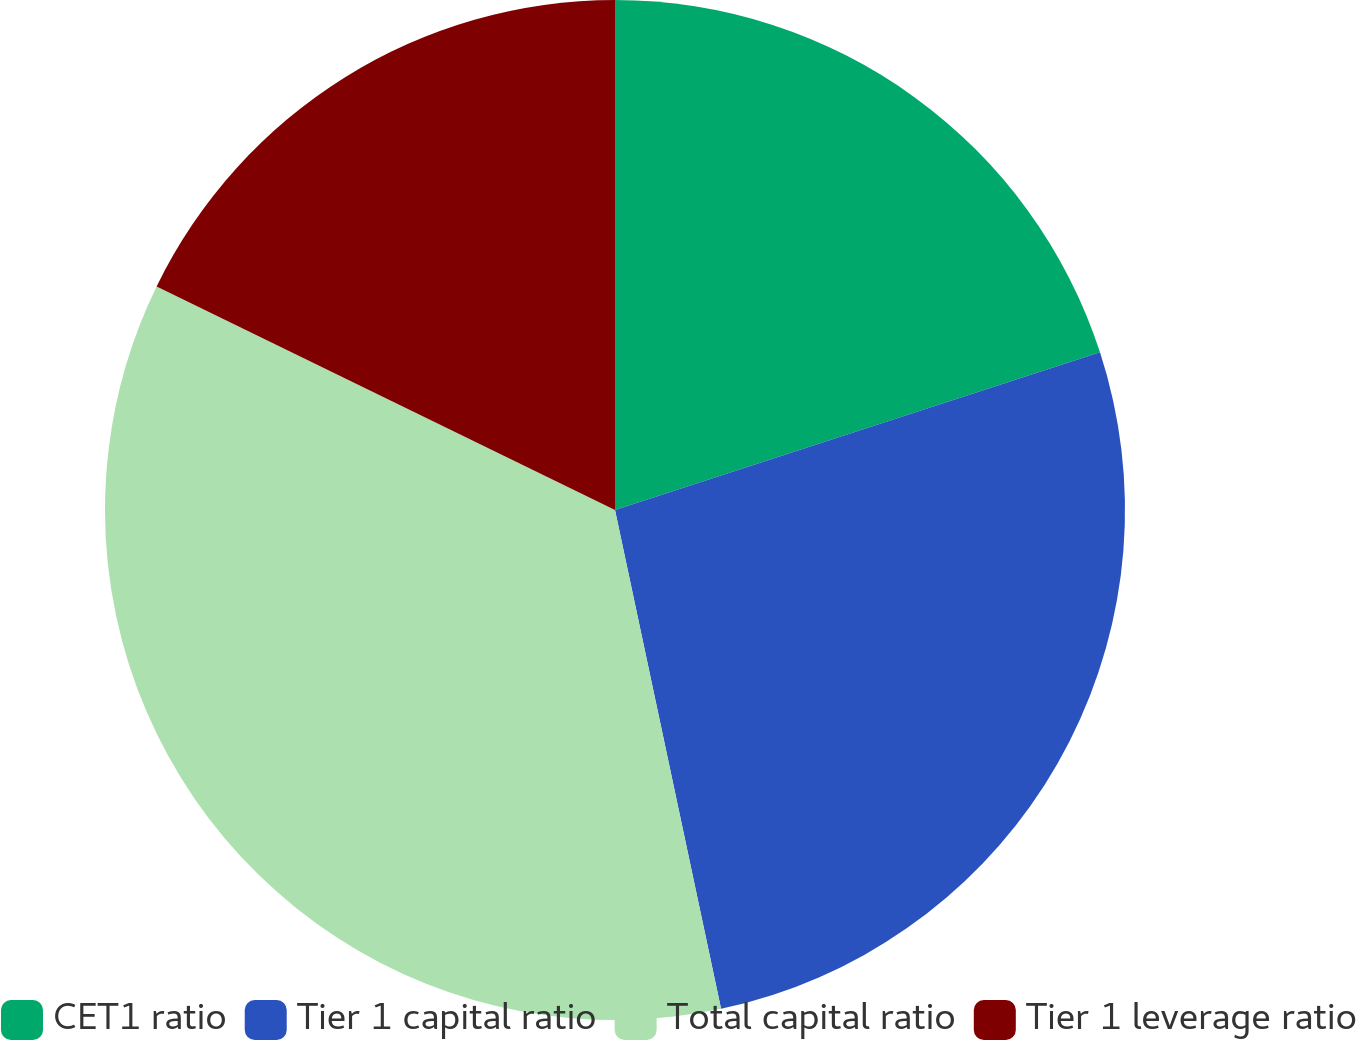Convert chart. <chart><loc_0><loc_0><loc_500><loc_500><pie_chart><fcel>CET1 ratio<fcel>Tier 1 capital ratio<fcel>Total capital ratio<fcel>Tier 1 leverage ratio<nl><fcel>20.0%<fcel>26.67%<fcel>35.56%<fcel>17.78%<nl></chart> 